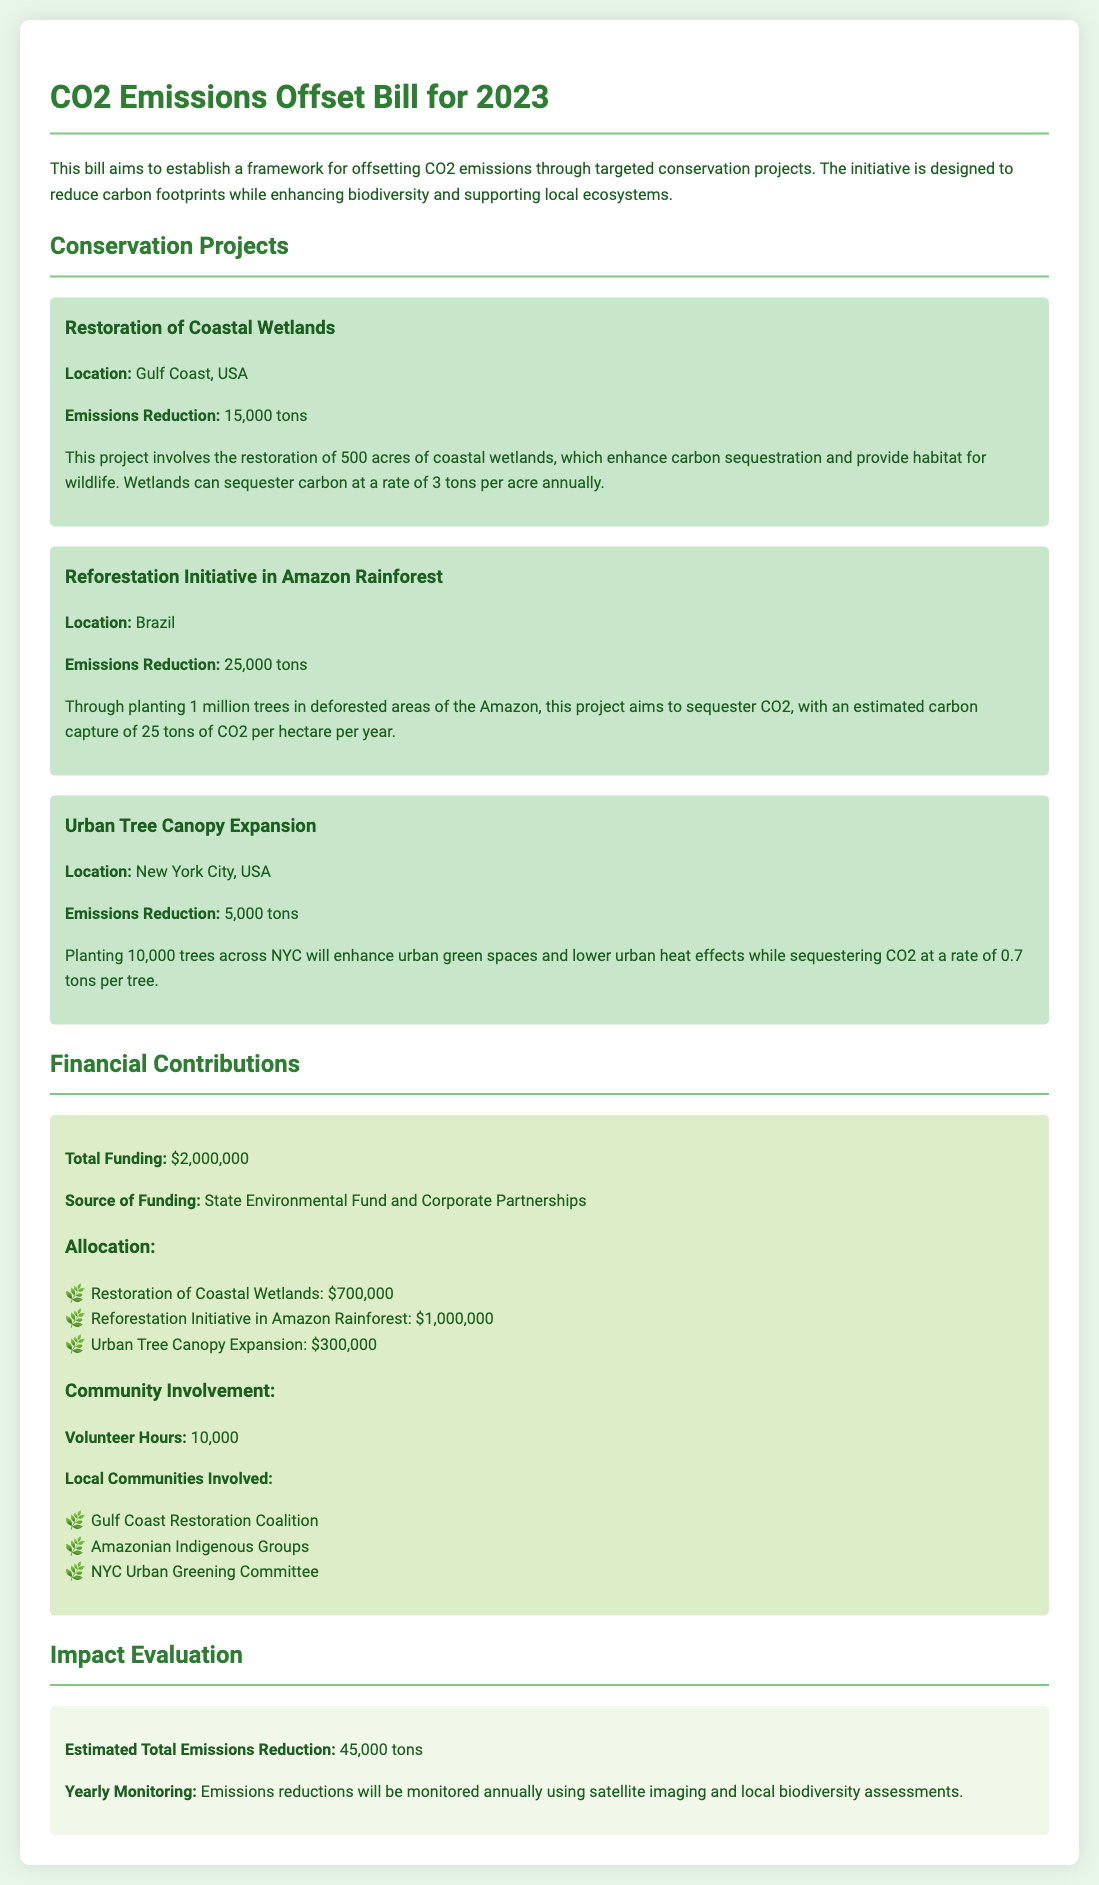What is the total emissions reduction? The total emissions reduction is provided in the impact evaluation section, totaling 45,000 tons.
Answer: 45,000 tons What is the location of the Reforestation Initiative? The location is indicated under the specific project details for the Reforestation Initiative, which is Brazil.
Answer: Brazil How many acres are involved in the Restoration of Coastal Wetlands project? The document specifies that 500 acres are involved in this project.
Answer: 500 acres What is the total funding amount for the initiatives? The document states the total funding for the projects is $2,000,000.
Answer: $2,000,000 How much funding is allocated for the Urban Tree Canopy Expansion? The financial contributions section lists $300,000 allocated for the Urban Tree Canopy Expansion.
Answer: $300,000 What is the emissions reduction rate for coastal wetlands per acre? The document mentions that wetlands can sequester carbon at a rate of 3 tons per acre annually.
Answer: 3 tons How many volunteer hours are contributed to the projects? The total volunteer hours are indicated in the community involvement section, which is 10,000 hours.
Answer: 10,000 Which group is involved in the Gulf Coast project? The document lists the Gulf Coast Restoration Coalition as involved with the Gulf Coast project.
Answer: Gulf Coast Restoration Coalition What year does the bill pertain to? The title of the document indicates that this is the CO2 Emissions Offset Bill for 2023.
Answer: 2023 